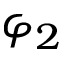<formula> <loc_0><loc_0><loc_500><loc_500>\varphi _ { 2 }</formula> 